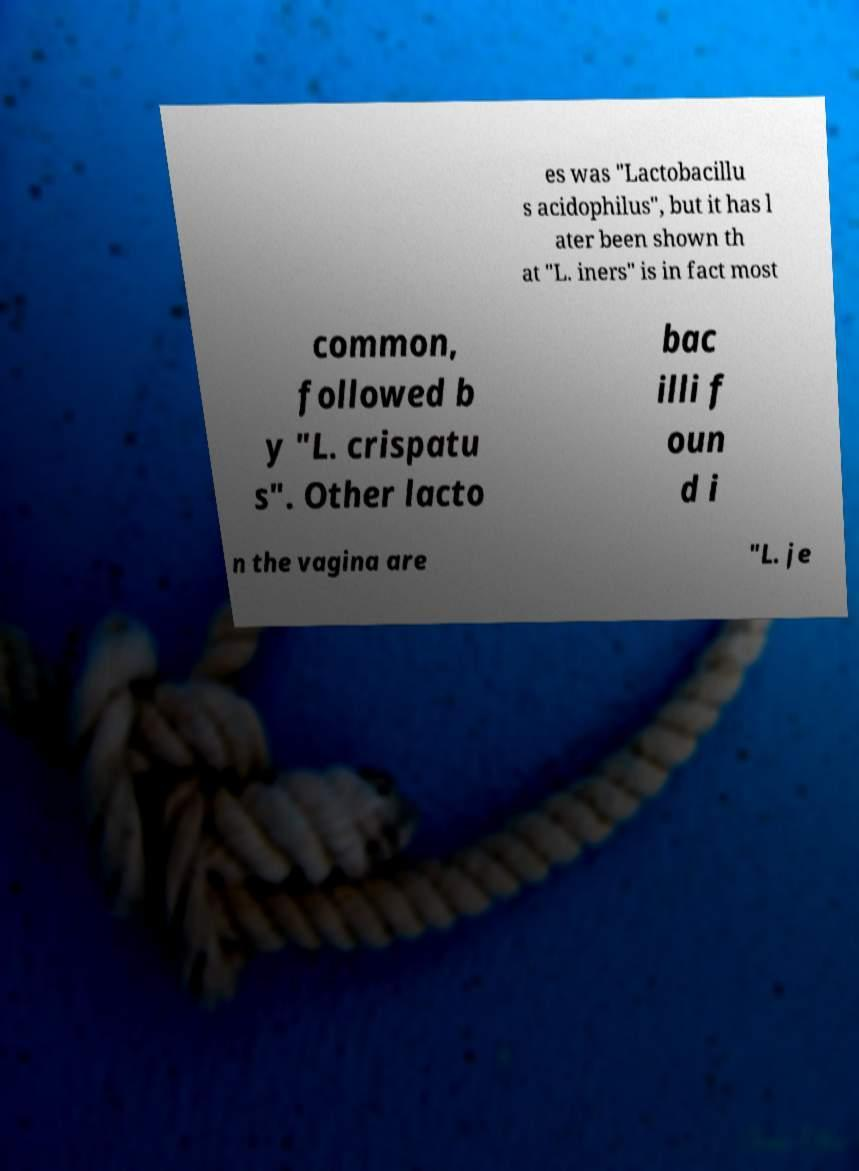I need the written content from this picture converted into text. Can you do that? es was "Lactobacillu s acidophilus", but it has l ater been shown th at "L. iners" is in fact most common, followed b y "L. crispatu s". Other lacto bac illi f oun d i n the vagina are "L. je 